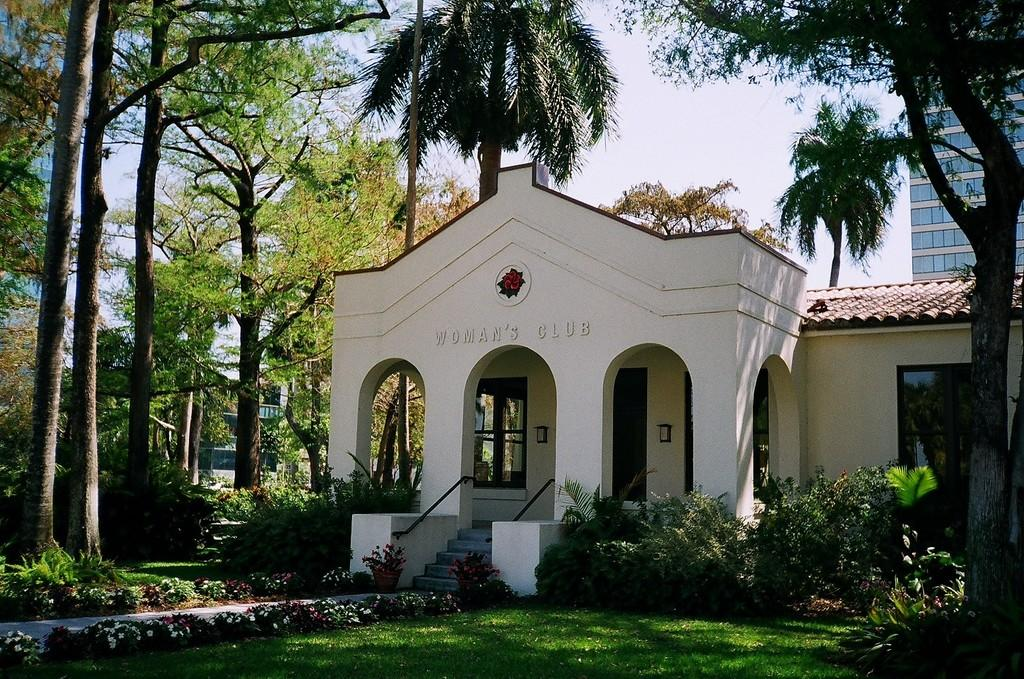What type of structures can be seen in the image? There are buildings in the image. What architectural feature is present in the image? There are stairs in the image. What can be used for entering or exiting a building in the image? There is a door in the image. What allows light and air to enter the buildings in the image? There are windows in the image. What type of vegetation is present in the image? There are plants, trees, and flowers in the image. What type of ground cover is present in the image? There is grass in the image. What is visible in the background of the image? The sky is visible in the background of the image. Can you tell me how many planes are flying in the image? There are no planes visible in the image. Who is the stranger standing next to the building in the image? There is no stranger present in the image. 